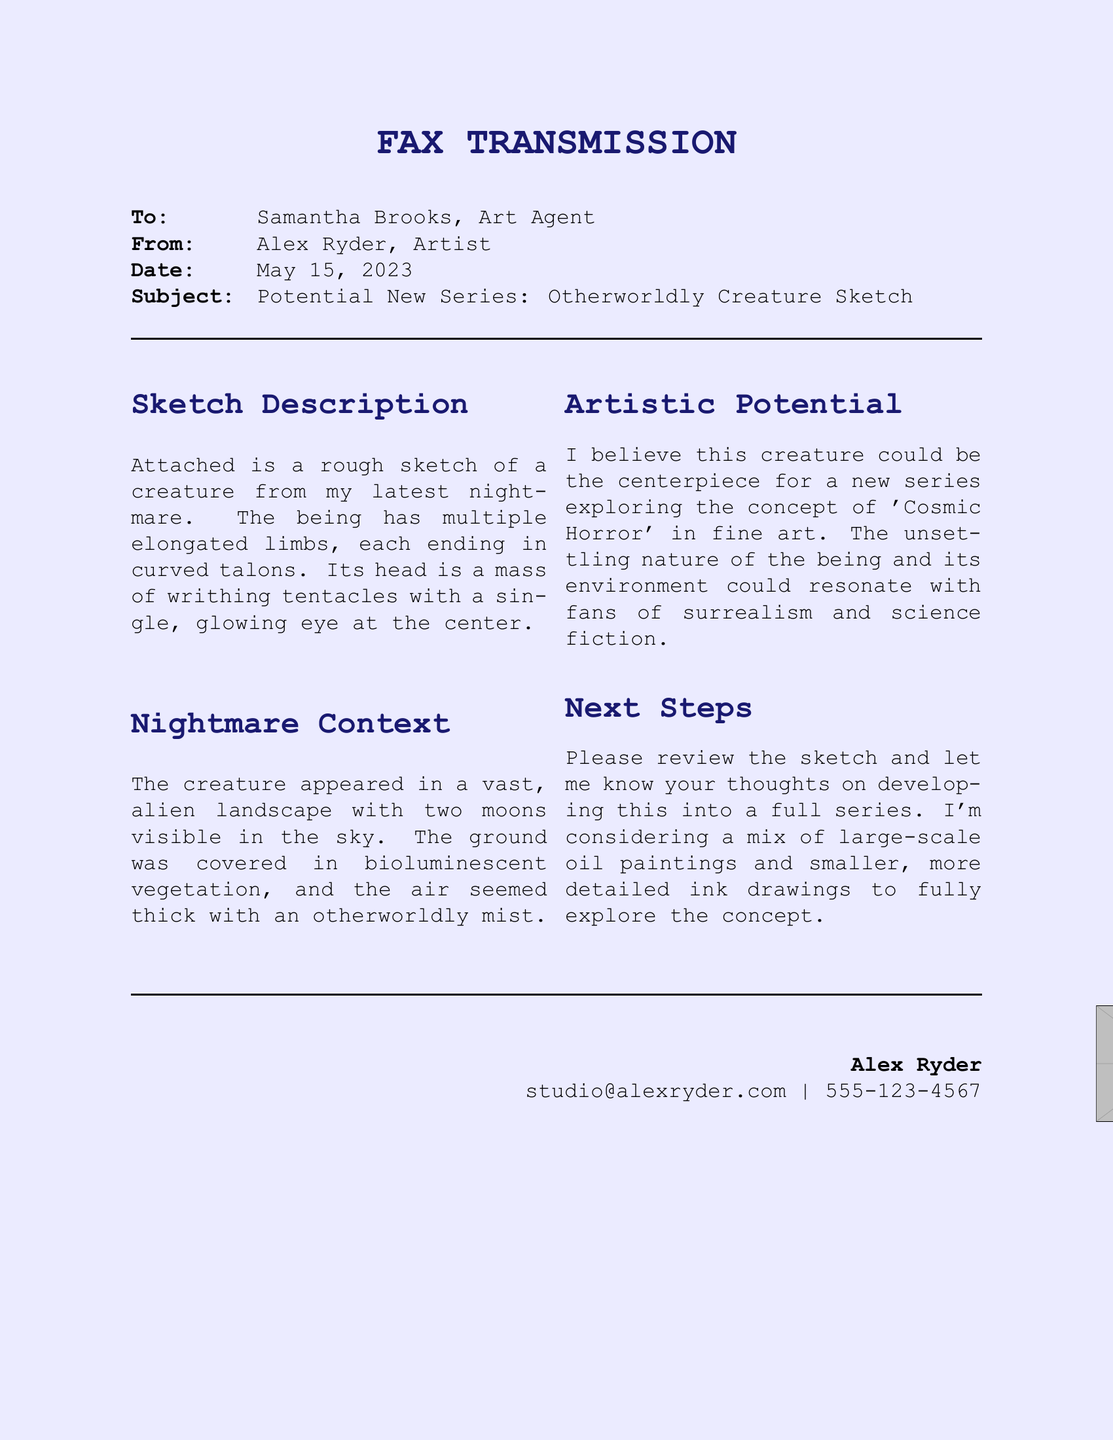what is the recipient's name? The recipient's name is listed at the top of the fax under "To" as Samantha Brooks.
Answer: Samantha Brooks what is the date of the fax? The date is specified in the document as May 15, 2023.
Answer: May 15, 2023 what is the subject of the fax? The subject is identified in the "Subject" line as "Potential New Series: Otherworldly Creature Sketch."
Answer: Potential New Series: Otherworldly Creature Sketch what color is the background of the document? The background color is mentioned at the beginning as moonlight.
Answer: moonlight how many moons are described in the nightmare context? The description mentions two moons visible in the sky of the nightmare landscape.
Answer: two what type of creatures is the sketch focused on? The sketch is focused on an otherworldly creature as indicated in the introduction.
Answer: otherworldly creature what is the main theme explored for the new series? The theme mentioned for the new series is 'Cosmic Horror.'
Answer: Cosmic Horror what is the preferred medium for larger artworks suggested in the fax? The medium suggested for large-scale works is oil paintings.
Answer: oil paintings what does the artist believe the creature and its environment will resonate with? The artist believes it will resonate with fans of surrealism and science fiction.
Answer: fans of surrealism and science fiction 